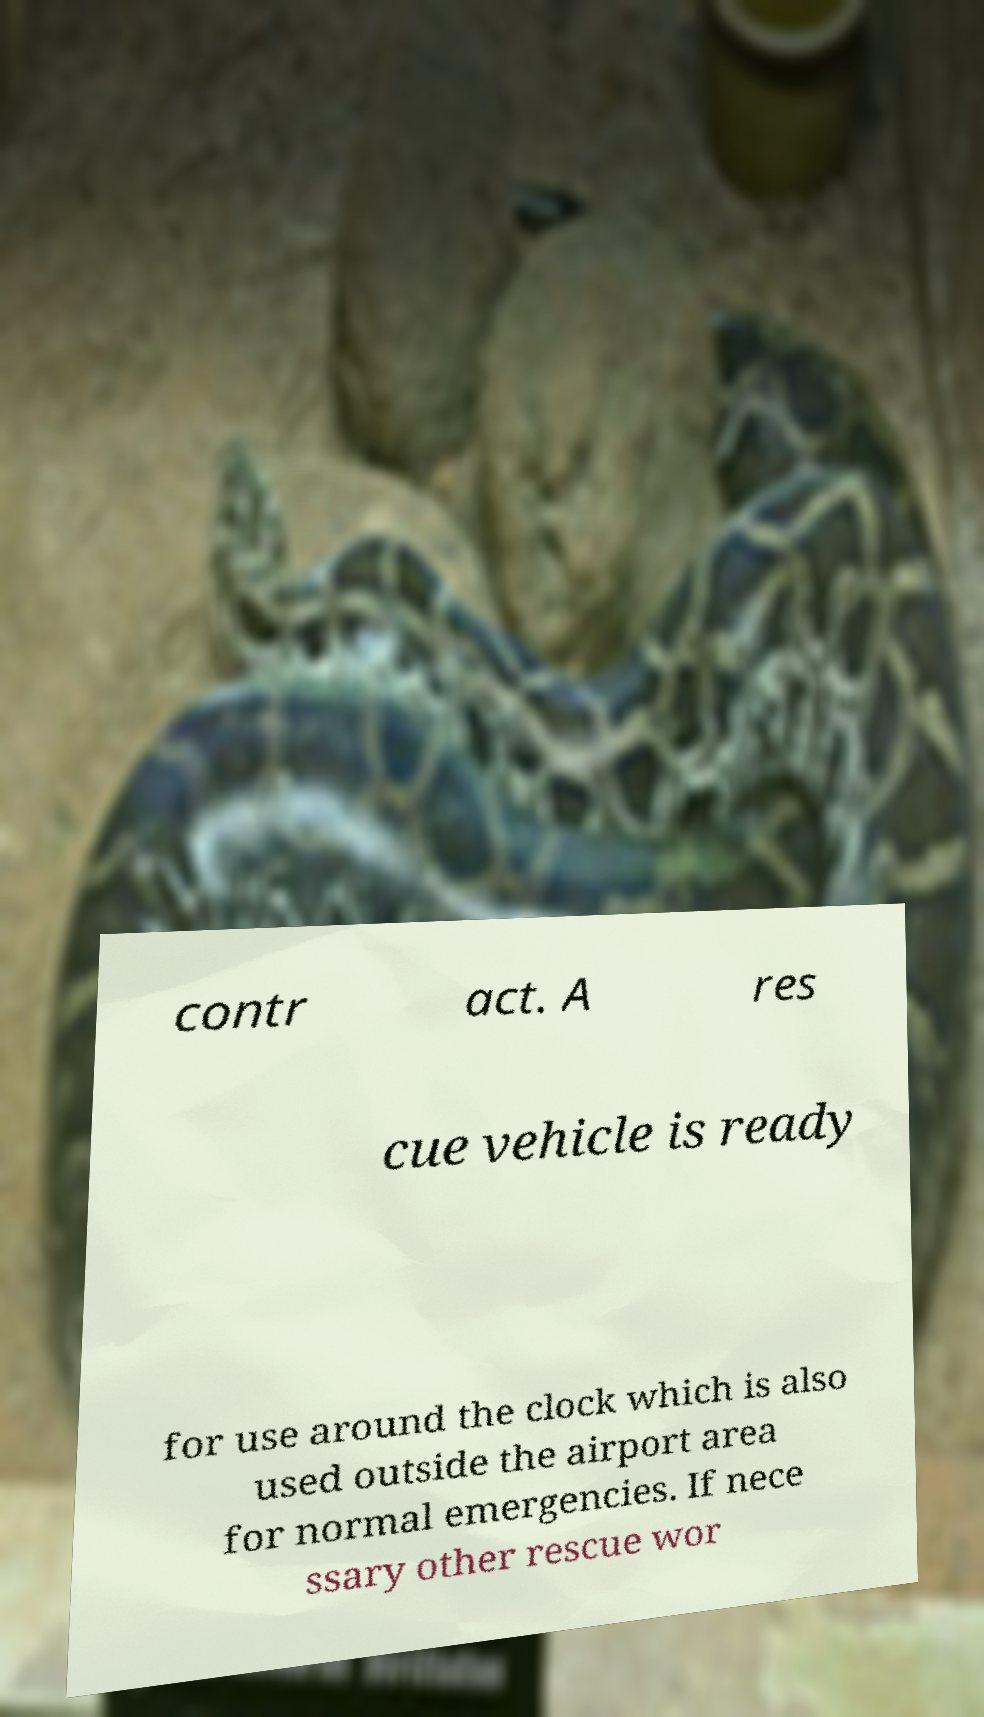There's text embedded in this image that I need extracted. Can you transcribe it verbatim? contr act. A res cue vehicle is ready for use around the clock which is also used outside the airport area for normal emergencies. If nece ssary other rescue wor 